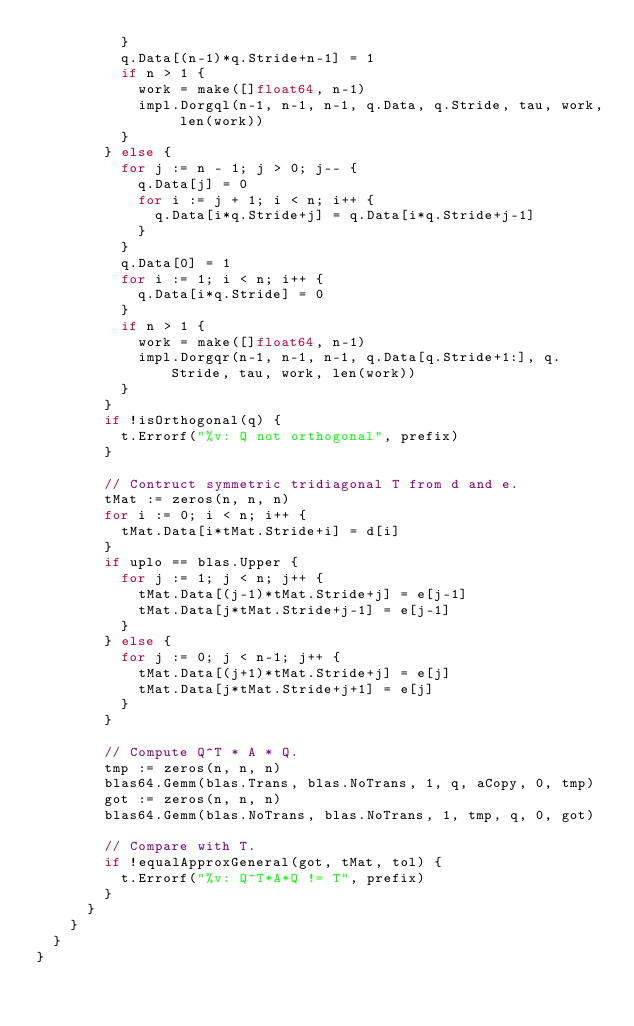<code> <loc_0><loc_0><loc_500><loc_500><_Go_>					}
					q.Data[(n-1)*q.Stride+n-1] = 1
					if n > 1 {
						work = make([]float64, n-1)
						impl.Dorgql(n-1, n-1, n-1, q.Data, q.Stride, tau, work, len(work))
					}
				} else {
					for j := n - 1; j > 0; j-- {
						q.Data[j] = 0
						for i := j + 1; i < n; i++ {
							q.Data[i*q.Stride+j] = q.Data[i*q.Stride+j-1]
						}
					}
					q.Data[0] = 1
					for i := 1; i < n; i++ {
						q.Data[i*q.Stride] = 0
					}
					if n > 1 {
						work = make([]float64, n-1)
						impl.Dorgqr(n-1, n-1, n-1, q.Data[q.Stride+1:], q.Stride, tau, work, len(work))
					}
				}
				if !isOrthogonal(q) {
					t.Errorf("%v: Q not orthogonal", prefix)
				}

				// Contruct symmetric tridiagonal T from d and e.
				tMat := zeros(n, n, n)
				for i := 0; i < n; i++ {
					tMat.Data[i*tMat.Stride+i] = d[i]
				}
				if uplo == blas.Upper {
					for j := 1; j < n; j++ {
						tMat.Data[(j-1)*tMat.Stride+j] = e[j-1]
						tMat.Data[j*tMat.Stride+j-1] = e[j-1]
					}
				} else {
					for j := 0; j < n-1; j++ {
						tMat.Data[(j+1)*tMat.Stride+j] = e[j]
						tMat.Data[j*tMat.Stride+j+1] = e[j]
					}
				}

				// Compute Q^T * A * Q.
				tmp := zeros(n, n, n)
				blas64.Gemm(blas.Trans, blas.NoTrans, 1, q, aCopy, 0, tmp)
				got := zeros(n, n, n)
				blas64.Gemm(blas.NoTrans, blas.NoTrans, 1, tmp, q, 0, got)

				// Compare with T.
				if !equalApproxGeneral(got, tMat, tol) {
					t.Errorf("%v: Q^T*A*Q != T", prefix)
				}
			}
		}
	}
}
</code> 